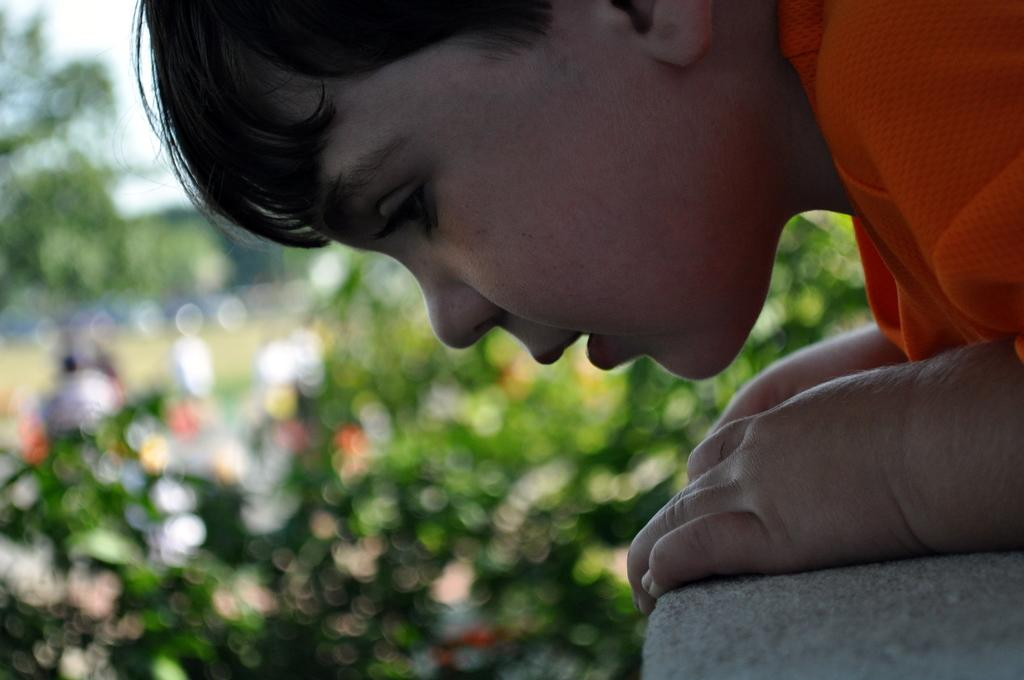What is the main subject of the image? The main subject of the image is a kid. What is the kid holding in the image? The kid is holding a wall in the image. Can you describe the background of the image? The background of the image is blurry. What type of pollution can be seen in the image? There is no pollution visible in the image. Is there a lamp present in the image? There is no lamp present in the image. Can you tell me how many potatoes are in the image? There are no potatoes present in the image. 